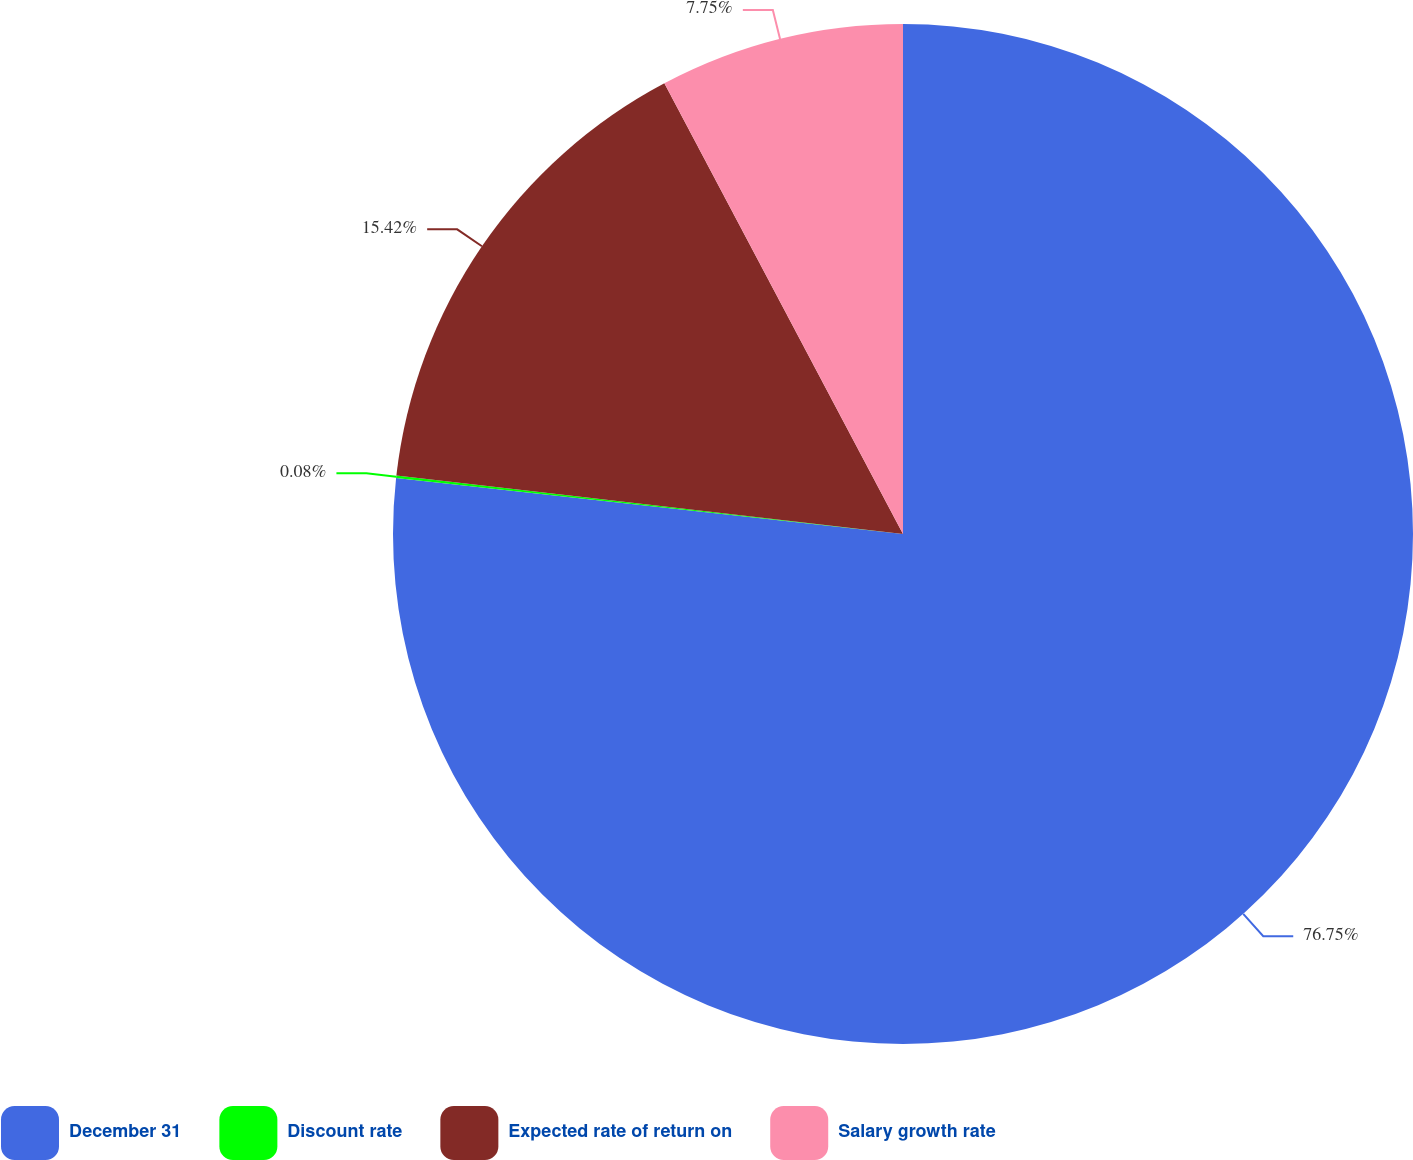Convert chart. <chart><loc_0><loc_0><loc_500><loc_500><pie_chart><fcel>December 31<fcel>Discount rate<fcel>Expected rate of return on<fcel>Salary growth rate<nl><fcel>76.76%<fcel>0.08%<fcel>15.42%<fcel>7.75%<nl></chart> 